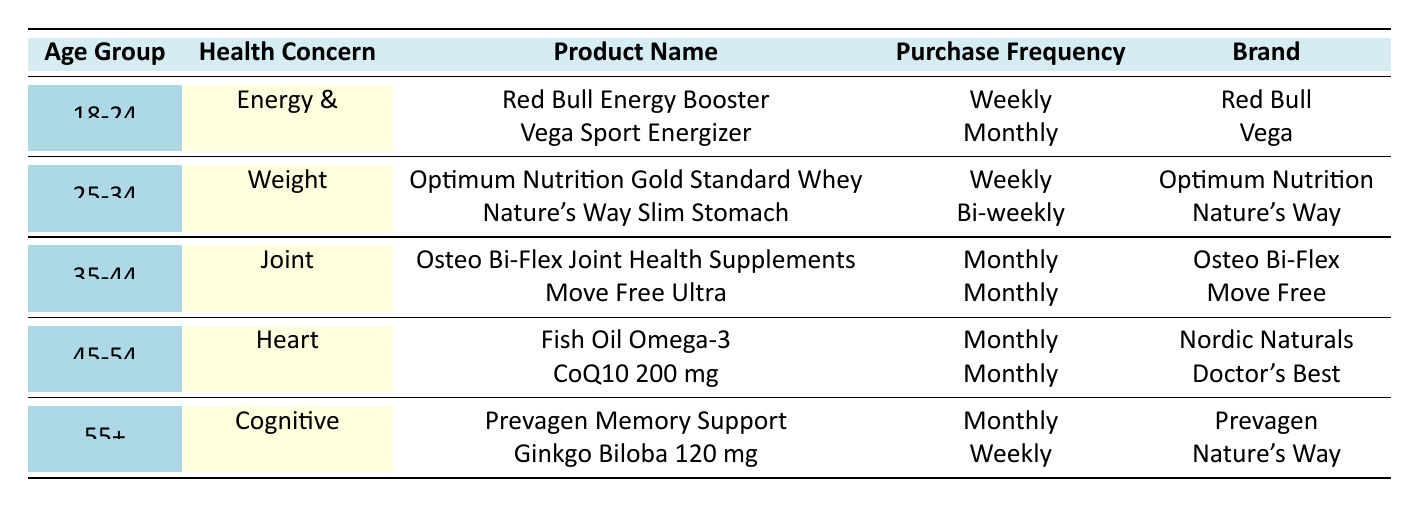What dietary supplement is most frequently purchased by the 18-24 age group? The table indicates that "Red Bull Energy Booster" is purchased weekly by the 18-24 age group, which is more frequent than "Vega Sport Energizer," which is purchased monthly. Thus, "Red Bull Energy Booster" is the most frequently purchased supplement for this age group.
Answer: Red Bull Energy Booster Which health concern is associated with the 45-54 age group? The table lists "Heart Health" as the health concern for the 45-54 age group, under which the products "Fish Oil Omega-3" and "CoQ10 200 mg" are listed.
Answer: Heart Health How many different products are noted for the 35-44 age group? The 35-44 age group has two products listed: "Osteo Bi-Flex Joint Health Supplements" and "Move Free Ultra." Therefore, there are a total of 2 products for this age group.
Answer: 2 Is "Ginkgo Biloba 120 mg" purchased weekly or monthly by the 55+ age group? The table specifies that "Ginkgo Biloba 120 mg" is purchased weekly by the 55+ age group, as reflected in the purchase frequency column next to the product name.
Answer: Weekly What is the purchase frequency of the "Optimum Nutrition Gold Standard Whey" supplement? According to the table, the purchase frequency for the "Optimum Nutrition Gold Standard Whey" supplement is listed as "Weekly," indicating how often it is bought by customers.
Answer: Weekly How many age groups prefer supplements that focus on Energy & Vitality? The table shows that only one age group, 18-24, focuses on Energy & Vitality, as it is the only demographic with this health concern listed.
Answer: 1 What is the average purchase frequency across all products listed for the 45-54 age group? Both products for the 45-54 age group are purchased monthly, making the average purchase frequency "Monthly" since both entries are the same.
Answer: Monthly Which product has the highest frequency of purchase for individuals aged 55 and over? The products for the 55+ age group are "Prevagen Memory Support" and "Ginkgo Biloba 120 mg," with "Ginkgo Biloba 120 mg" being purchased weekly compared to the monthly frequency of "Prevagen Memory Support." Therefore, "Ginkgo Biloba 120 mg" has the highest purchase frequency in this age group.
Answer: Ginkgo Biloba 120 mg Is there any product listed that is purchased bi-weekly? The table indicates "Nature's Way Slim Stomach" is purchased bi-weekly by the 25-34 age group, confirming that there is indeed a product listed with that purchase frequency.
Answer: Yes How many brands are represented for the 25-34 age group? The 25-34 age group lists two products: "Optimum Nutrition Gold Standard Whey" (Optimum Nutrition) and "Nature's Way Slim Stomach" (Nature's Way), indicating that there are two different brands represented.
Answer: 2 